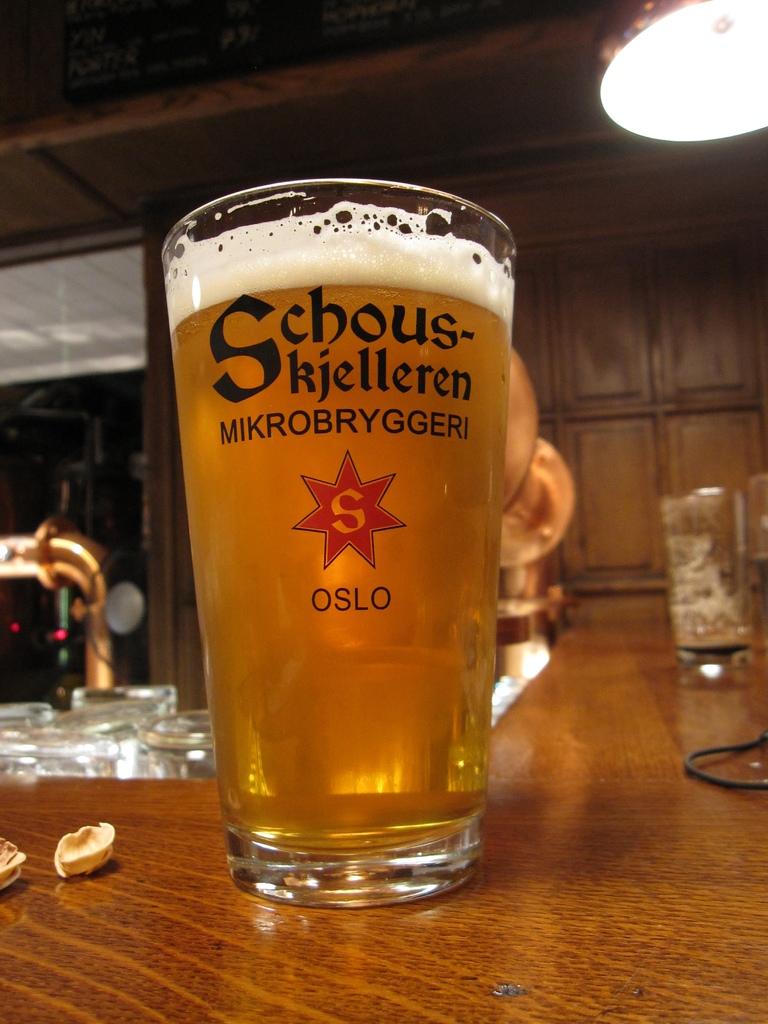What letter is in the red star on the glass?
Make the answer very short. S. 